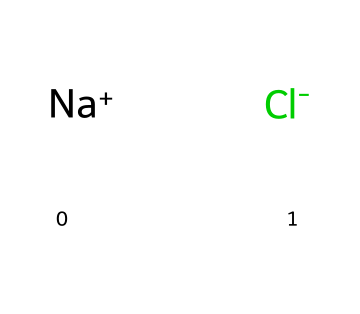What is the chemical name of this structure? The SMILES notation [Na+].[Cl-] indicates the presence of sodium ion and chloride ion, which together form sodium chloride. Therefore, the chemical name is sodium chloride.
Answer: sodium chloride How many atoms are present in this chemical structure? The structure consists of one sodium atom and one chlorine atom, totaling two atoms.
Answer: 2 What type of compound is represented here? The presence of a sodium ion and a chloride ion indicates that this is an ionic compound, specifically an electrolyte.
Answer: ionic compound Is this chemical soluble in water? Sodium chloride is known to be highly soluble in water due to its ionic nature, which allows for dissociation into Na+ and Cl- ions.
Answer: yes What property of sodium chloride makes it useful in sweat-resistant makeup? Sodium chloride helps to control moisture and enhance the durability of makeup in humid conditions, making it effective in outdoor settings.
Answer: moisture control How many bonds are involved in the formation of sodium chloride? Sodium chloride forms through one ionic bond between the positively charged sodium ion and the negatively charged chloride ion, making it a single bond formation.
Answer: 1 Why is sodium chloride classified as an electrolyte? Electrolytes are substances that dissociate into ions in solution; sodium chloride dissociates into Na+ and Cl- ions, which conduct electricity, hence its classification as an electrolyte.
Answer: because it dissociates into ions 